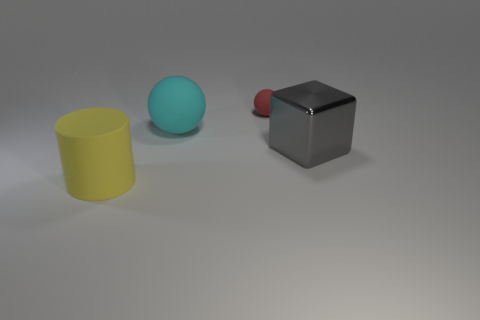Add 4 big cyan spheres. How many objects exist? 8 Subtract all cyan spheres. How many spheres are left? 1 Subtract all cylinders. How many objects are left? 3 Subtract 1 blocks. How many blocks are left? 0 Subtract all gray cubes. How many red balls are left? 1 Subtract all big red shiny cubes. Subtract all spheres. How many objects are left? 2 Add 1 things. How many things are left? 5 Add 2 tiny green rubber cylinders. How many tiny green rubber cylinders exist? 2 Subtract 0 green cylinders. How many objects are left? 4 Subtract all cyan spheres. Subtract all green cylinders. How many spheres are left? 1 